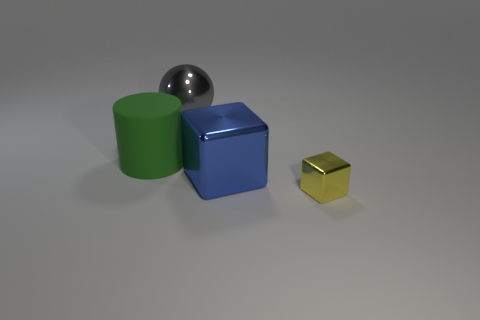Add 3 tiny green metallic objects. How many objects exist? 7 Subtract all yellow blocks. Subtract all gray spheres. How many blocks are left? 1 Subtract all cylinders. How many objects are left? 3 Subtract all blue shiny things. Subtract all cyan rubber cylinders. How many objects are left? 3 Add 4 blue metallic objects. How many blue metallic objects are left? 5 Add 2 big red cylinders. How many big red cylinders exist? 2 Subtract 0 gray cylinders. How many objects are left? 4 